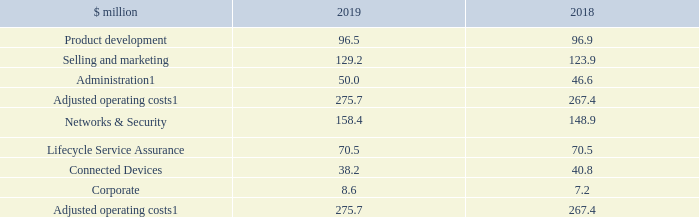Operating costs
Total Group adjusted operating costs were up $8.3 million or 3.1 per cent in 2019 compared to last year, broadly in line with inflation. The emphasis remained on effective resource allocation and careful cost management. The overall investment in product development was maintained, with continuing focus on high-growth, high-margin areas. Investment in the sales and marketing organisation was targeted on expanding our key account management programme to drive incremental business with our most valuable customers and developing routes to market for our new technologies to a broadening customer base. Administration costs in 2019 reflected an inflationary increase and higher corporate costs, primarily due to CEO transition.
Segmentally, investment continued in Networks & Security, where we see the most near-term opportunities for growth, particularly in relation to 400G high-speed Ethernet and our Positioning business. A new General Manager joined Lifecycle Service Assurance in October and a review is in progress to evolve the business and optimise the organisational structure to expand the customer base and deliver on our growth agenda. Proactive cost management has once again been demonstrated within Connected Devices, where we have seen a decrease in legacy product revenue year-on-year. As stated above, corporate costs in 2019 included costs associated with CEO transition.
Note
1. Before exceptional items, acquisition related costs, acquired intangible asset amortisation and share-based payment amounting to $4.3 million in total (2018 $19.6 million).
For adjusted operating costs, what was the amount of  Before exceptional items, acquisition related costs, acquired intangible asset amortisation and share-based payment in 2019? $4.3 million in total. What is the change in the total group adjusted operating costs? Up $8.3 million. What are the different business segments considered in the operating costs? Networks & security, lifecycle service assurance, connected devices, corporate, product development, selling and marketing, administration. In which year was the amount of operating costs under Networks & Security larger? 158.4>148.9
Answer: 2019. What was the change in costs under Corporate?
Answer scale should be: million. 8.6-7.2
Answer: 1.4. What was the percentage change in costs under Corporate?
Answer scale should be: percent. (8.6-7.2)/7.2
Answer: 19.44. 